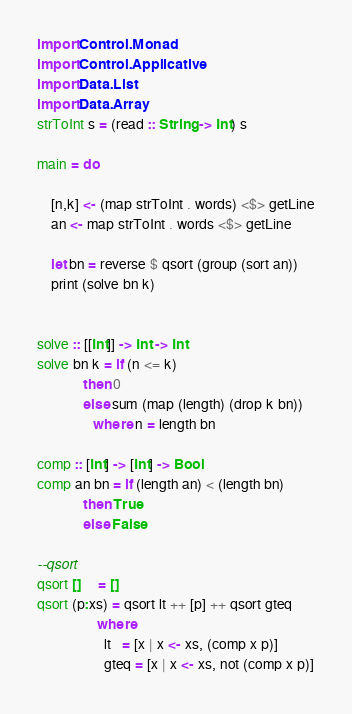<code> <loc_0><loc_0><loc_500><loc_500><_Haskell_>import Control.Monad
import Control.Applicative
import Data.List
import Data.Array
strToInt s = (read :: String -> Int) s

main = do

    [n,k] <- (map strToInt . words) <$> getLine
    an <- map strToInt . words <$> getLine
    
    let bn = reverse $ qsort (group (sort an))
    print (solve bn k)


solve :: [[Int]] -> Int -> Int
solve bn k = if (n <= k)
             then 0
             else sum (map (length) (drop k bn))
                where n = length bn

comp :: [Int] -> [Int] -> Bool
comp an bn = if (length an) < (length bn)
             then True
             else False

--qsort
qsort []     = []
qsort (p:xs) = qsort lt ++ [p] ++ qsort gteq
                 where
                   lt   = [x | x <- xs, (comp x p)]
                   gteq = [x | x <- xs, not (comp x p)]</code> 